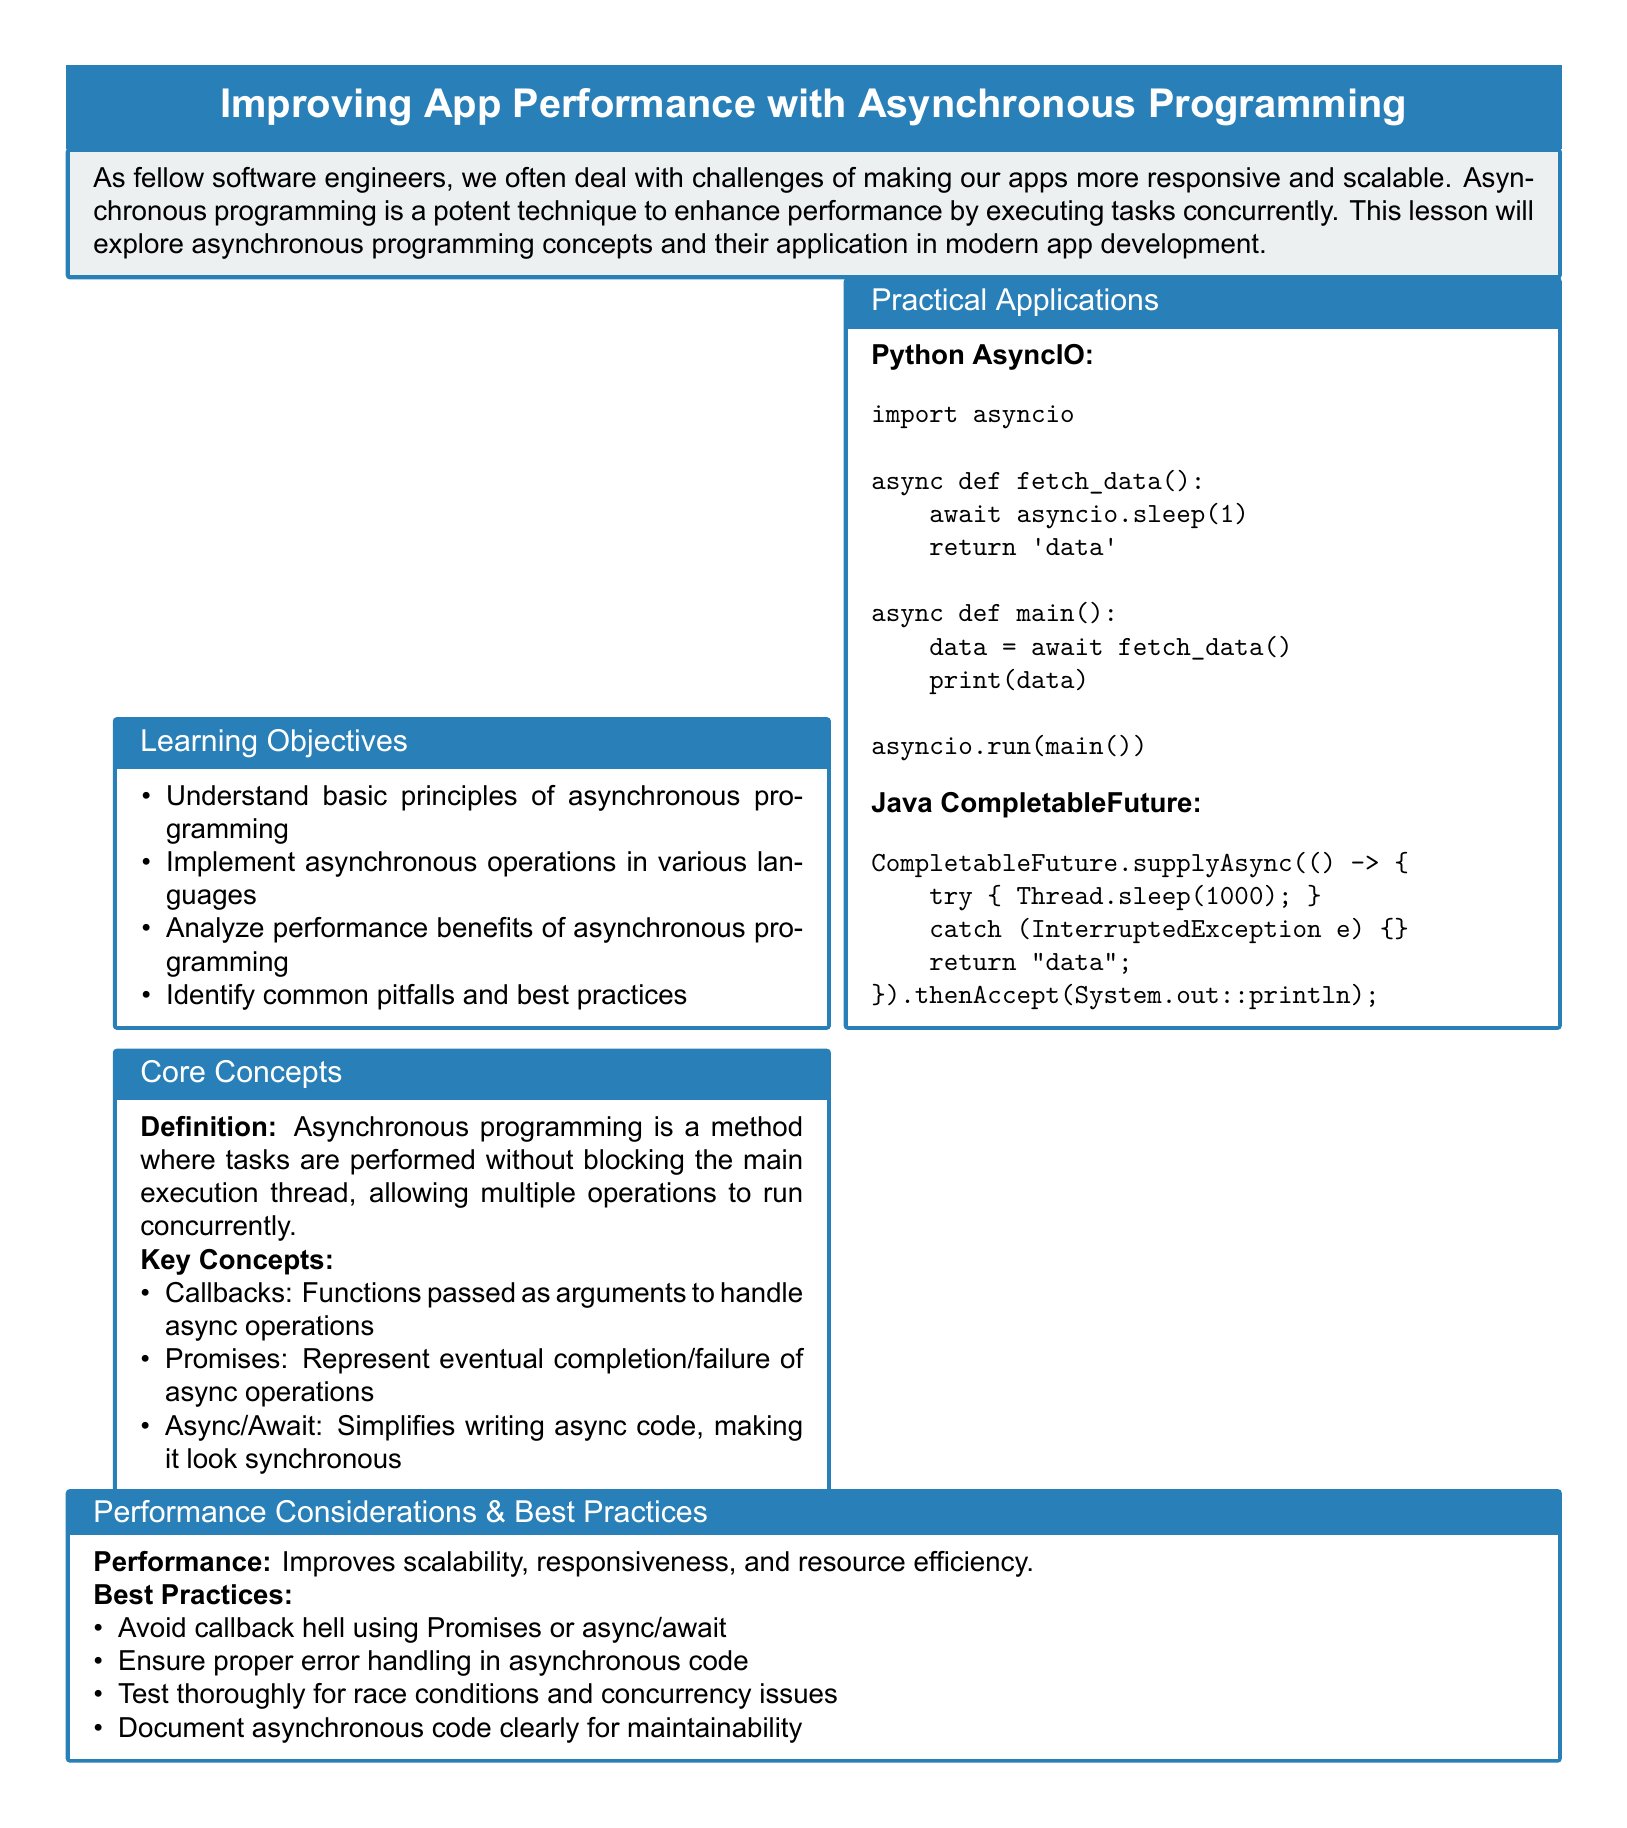What are the learning objectives? The learning objectives listed in the document include understanding principles, implementing operations, analyzing benefits, and identifying pitfalls.
Answer: Understanding basic principles of asynchronous programming, Implement asynchronous operations in various languages, Analyze performance benefits of asynchronous programming, Identify common pitfalls and best practices What does asynchronous programming allow? Asynchronous programming allows multiple operations to run concurrently without blocking the main execution thread.
Answer: Multiple operations to run concurrently What is an example of Python asynchronous code in the document? The document provides an example of Python asynchronous code using the asyncio library that fetches data.
Answer: import asyncio async def fetch_data(): await asyncio.sleep(1) return 'data' async def main(): data = await fetch_data() print(data) asyncio.run(main()) What are the best practices for asynchronous programming? The best practices outlined include avoiding callback hell, ensuring error handling, testing for race conditions, and documenting code.
Answer: Avoid callback hell using Promises or async/await, Ensure proper error handling in asynchronous code, Test thoroughly for race conditions and concurrency issues, Document asynchronous code clearly for maintainability What is the main focus of the lesson plan? The lesson plan focuses on improving app performance by exploring asynchronous programming concepts and their applications.
Answer: Improving App Performance with Asynchronous Programming 